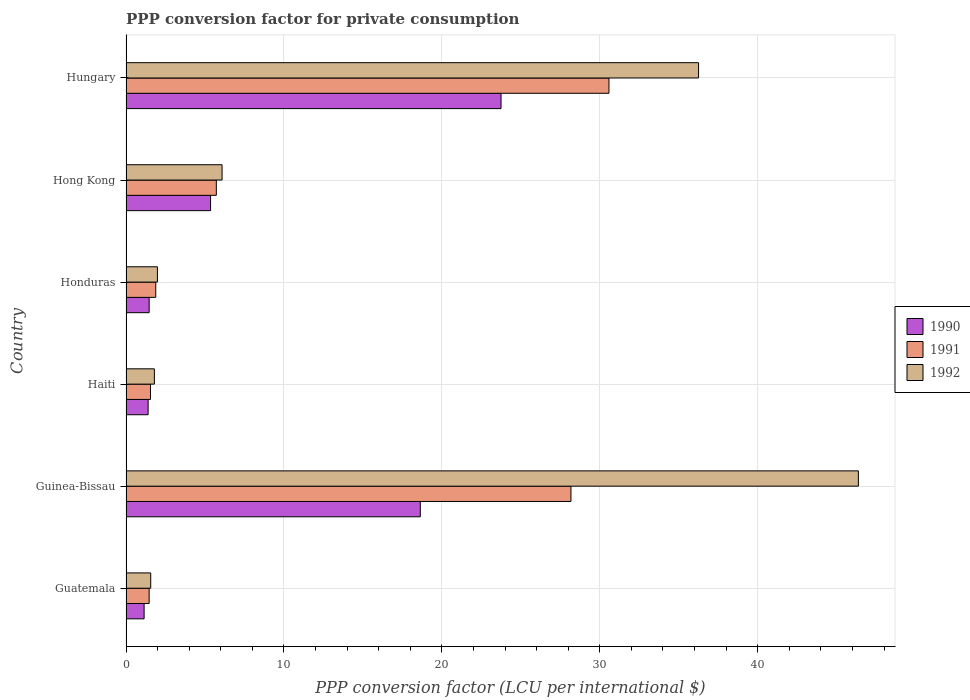How many groups of bars are there?
Offer a very short reply. 6. Are the number of bars on each tick of the Y-axis equal?
Make the answer very short. Yes. How many bars are there on the 4th tick from the bottom?
Make the answer very short. 3. What is the label of the 3rd group of bars from the top?
Your response must be concise. Honduras. In how many cases, is the number of bars for a given country not equal to the number of legend labels?
Provide a succinct answer. 0. What is the PPP conversion factor for private consumption in 1992 in Hungary?
Provide a succinct answer. 36.26. Across all countries, what is the maximum PPP conversion factor for private consumption in 1990?
Your answer should be very brief. 23.75. Across all countries, what is the minimum PPP conversion factor for private consumption in 1990?
Provide a short and direct response. 1.15. In which country was the PPP conversion factor for private consumption in 1992 maximum?
Your answer should be very brief. Guinea-Bissau. In which country was the PPP conversion factor for private consumption in 1990 minimum?
Your answer should be very brief. Guatemala. What is the total PPP conversion factor for private consumption in 1992 in the graph?
Give a very brief answer. 94.06. What is the difference between the PPP conversion factor for private consumption in 1991 in Hong Kong and that in Hungary?
Your answer should be very brief. -24.86. What is the difference between the PPP conversion factor for private consumption in 1991 in Honduras and the PPP conversion factor for private consumption in 1992 in Haiti?
Make the answer very short. 0.09. What is the average PPP conversion factor for private consumption in 1990 per country?
Give a very brief answer. 8.63. What is the difference between the PPP conversion factor for private consumption in 1991 and PPP conversion factor for private consumption in 1990 in Guinea-Bissau?
Make the answer very short. 9.54. What is the ratio of the PPP conversion factor for private consumption in 1990 in Guinea-Bissau to that in Honduras?
Make the answer very short. 12.71. Is the PPP conversion factor for private consumption in 1990 in Guatemala less than that in Haiti?
Offer a terse response. Yes. Is the difference between the PPP conversion factor for private consumption in 1991 in Guatemala and Haiti greater than the difference between the PPP conversion factor for private consumption in 1990 in Guatemala and Haiti?
Your answer should be very brief. Yes. What is the difference between the highest and the second highest PPP conversion factor for private consumption in 1992?
Offer a terse response. 10.12. What is the difference between the highest and the lowest PPP conversion factor for private consumption in 1991?
Your answer should be very brief. 29.12. In how many countries, is the PPP conversion factor for private consumption in 1992 greater than the average PPP conversion factor for private consumption in 1992 taken over all countries?
Your response must be concise. 2. Is the sum of the PPP conversion factor for private consumption in 1991 in Guatemala and Haiti greater than the maximum PPP conversion factor for private consumption in 1992 across all countries?
Your answer should be compact. No. Does the graph contain grids?
Ensure brevity in your answer.  Yes. How many legend labels are there?
Give a very brief answer. 3. How are the legend labels stacked?
Provide a succinct answer. Vertical. What is the title of the graph?
Ensure brevity in your answer.  PPP conversion factor for private consumption. Does "1985" appear as one of the legend labels in the graph?
Your answer should be compact. No. What is the label or title of the X-axis?
Provide a succinct answer. PPP conversion factor (LCU per international $). What is the PPP conversion factor (LCU per international $) in 1990 in Guatemala?
Give a very brief answer. 1.15. What is the PPP conversion factor (LCU per international $) of 1991 in Guatemala?
Provide a succinct answer. 1.46. What is the PPP conversion factor (LCU per international $) of 1992 in Guatemala?
Provide a succinct answer. 1.56. What is the PPP conversion factor (LCU per international $) of 1990 in Guinea-Bissau?
Your answer should be compact. 18.64. What is the PPP conversion factor (LCU per international $) in 1991 in Guinea-Bissau?
Your answer should be very brief. 28.18. What is the PPP conversion factor (LCU per international $) of 1992 in Guinea-Bissau?
Your answer should be compact. 46.38. What is the PPP conversion factor (LCU per international $) of 1990 in Haiti?
Provide a short and direct response. 1.4. What is the PPP conversion factor (LCU per international $) of 1991 in Haiti?
Give a very brief answer. 1.55. What is the PPP conversion factor (LCU per international $) in 1992 in Haiti?
Ensure brevity in your answer.  1.8. What is the PPP conversion factor (LCU per international $) in 1990 in Honduras?
Offer a terse response. 1.47. What is the PPP conversion factor (LCU per international $) in 1991 in Honduras?
Your response must be concise. 1.88. What is the PPP conversion factor (LCU per international $) of 1992 in Honduras?
Provide a short and direct response. 1.99. What is the PPP conversion factor (LCU per international $) in 1990 in Hong Kong?
Provide a succinct answer. 5.35. What is the PPP conversion factor (LCU per international $) in 1991 in Hong Kong?
Keep it short and to the point. 5.72. What is the PPP conversion factor (LCU per international $) of 1992 in Hong Kong?
Keep it short and to the point. 6.08. What is the PPP conversion factor (LCU per international $) of 1990 in Hungary?
Provide a short and direct response. 23.75. What is the PPP conversion factor (LCU per international $) of 1991 in Hungary?
Keep it short and to the point. 30.58. What is the PPP conversion factor (LCU per international $) of 1992 in Hungary?
Provide a succinct answer. 36.26. Across all countries, what is the maximum PPP conversion factor (LCU per international $) in 1990?
Provide a short and direct response. 23.75. Across all countries, what is the maximum PPP conversion factor (LCU per international $) in 1991?
Give a very brief answer. 30.58. Across all countries, what is the maximum PPP conversion factor (LCU per international $) in 1992?
Provide a succinct answer. 46.38. Across all countries, what is the minimum PPP conversion factor (LCU per international $) in 1990?
Give a very brief answer. 1.15. Across all countries, what is the minimum PPP conversion factor (LCU per international $) of 1991?
Offer a terse response. 1.46. Across all countries, what is the minimum PPP conversion factor (LCU per international $) in 1992?
Offer a very short reply. 1.56. What is the total PPP conversion factor (LCU per international $) of 1990 in the graph?
Make the answer very short. 51.75. What is the total PPP conversion factor (LCU per international $) of 1991 in the graph?
Provide a short and direct response. 69.38. What is the total PPP conversion factor (LCU per international $) of 1992 in the graph?
Offer a terse response. 94.06. What is the difference between the PPP conversion factor (LCU per international $) in 1990 in Guatemala and that in Guinea-Bissau?
Provide a succinct answer. -17.49. What is the difference between the PPP conversion factor (LCU per international $) of 1991 in Guatemala and that in Guinea-Bissau?
Your answer should be very brief. -26.71. What is the difference between the PPP conversion factor (LCU per international $) of 1992 in Guatemala and that in Guinea-Bissau?
Provide a succinct answer. -44.81. What is the difference between the PPP conversion factor (LCU per international $) in 1990 in Guatemala and that in Haiti?
Your response must be concise. -0.25. What is the difference between the PPP conversion factor (LCU per international $) of 1991 in Guatemala and that in Haiti?
Provide a succinct answer. -0.09. What is the difference between the PPP conversion factor (LCU per international $) of 1992 in Guatemala and that in Haiti?
Give a very brief answer. -0.23. What is the difference between the PPP conversion factor (LCU per international $) of 1990 in Guatemala and that in Honduras?
Offer a very short reply. -0.32. What is the difference between the PPP conversion factor (LCU per international $) in 1991 in Guatemala and that in Honduras?
Offer a terse response. -0.42. What is the difference between the PPP conversion factor (LCU per international $) in 1992 in Guatemala and that in Honduras?
Your answer should be very brief. -0.42. What is the difference between the PPP conversion factor (LCU per international $) of 1990 in Guatemala and that in Hong Kong?
Make the answer very short. -4.21. What is the difference between the PPP conversion factor (LCU per international $) of 1991 in Guatemala and that in Hong Kong?
Ensure brevity in your answer.  -4.25. What is the difference between the PPP conversion factor (LCU per international $) in 1992 in Guatemala and that in Hong Kong?
Keep it short and to the point. -4.52. What is the difference between the PPP conversion factor (LCU per international $) in 1990 in Guatemala and that in Hungary?
Your response must be concise. -22.6. What is the difference between the PPP conversion factor (LCU per international $) of 1991 in Guatemala and that in Hungary?
Your answer should be very brief. -29.12. What is the difference between the PPP conversion factor (LCU per international $) of 1992 in Guatemala and that in Hungary?
Provide a succinct answer. -34.69. What is the difference between the PPP conversion factor (LCU per international $) of 1990 in Guinea-Bissau and that in Haiti?
Give a very brief answer. 17.24. What is the difference between the PPP conversion factor (LCU per international $) of 1991 in Guinea-Bissau and that in Haiti?
Your response must be concise. 26.63. What is the difference between the PPP conversion factor (LCU per international $) in 1992 in Guinea-Bissau and that in Haiti?
Your response must be concise. 44.58. What is the difference between the PPP conversion factor (LCU per international $) of 1990 in Guinea-Bissau and that in Honduras?
Provide a succinct answer. 17.17. What is the difference between the PPP conversion factor (LCU per international $) in 1991 in Guinea-Bissau and that in Honduras?
Your response must be concise. 26.29. What is the difference between the PPP conversion factor (LCU per international $) in 1992 in Guinea-Bissau and that in Honduras?
Ensure brevity in your answer.  44.39. What is the difference between the PPP conversion factor (LCU per international $) of 1990 in Guinea-Bissau and that in Hong Kong?
Provide a succinct answer. 13.28. What is the difference between the PPP conversion factor (LCU per international $) of 1991 in Guinea-Bissau and that in Hong Kong?
Ensure brevity in your answer.  22.46. What is the difference between the PPP conversion factor (LCU per international $) in 1992 in Guinea-Bissau and that in Hong Kong?
Provide a short and direct response. 40.29. What is the difference between the PPP conversion factor (LCU per international $) of 1990 in Guinea-Bissau and that in Hungary?
Provide a succinct answer. -5.11. What is the difference between the PPP conversion factor (LCU per international $) in 1991 in Guinea-Bissau and that in Hungary?
Your response must be concise. -2.41. What is the difference between the PPP conversion factor (LCU per international $) in 1992 in Guinea-Bissau and that in Hungary?
Offer a terse response. 10.12. What is the difference between the PPP conversion factor (LCU per international $) in 1990 in Haiti and that in Honduras?
Keep it short and to the point. -0.07. What is the difference between the PPP conversion factor (LCU per international $) of 1991 in Haiti and that in Honduras?
Provide a succinct answer. -0.33. What is the difference between the PPP conversion factor (LCU per international $) in 1992 in Haiti and that in Honduras?
Provide a short and direct response. -0.19. What is the difference between the PPP conversion factor (LCU per international $) of 1990 in Haiti and that in Hong Kong?
Your answer should be very brief. -3.95. What is the difference between the PPP conversion factor (LCU per international $) of 1991 in Haiti and that in Hong Kong?
Make the answer very short. -4.17. What is the difference between the PPP conversion factor (LCU per international $) of 1992 in Haiti and that in Hong Kong?
Your answer should be compact. -4.29. What is the difference between the PPP conversion factor (LCU per international $) of 1990 in Haiti and that in Hungary?
Your answer should be compact. -22.35. What is the difference between the PPP conversion factor (LCU per international $) in 1991 in Haiti and that in Hungary?
Your answer should be very brief. -29.03. What is the difference between the PPP conversion factor (LCU per international $) of 1992 in Haiti and that in Hungary?
Make the answer very short. -34.46. What is the difference between the PPP conversion factor (LCU per international $) of 1990 in Honduras and that in Hong Kong?
Keep it short and to the point. -3.89. What is the difference between the PPP conversion factor (LCU per international $) in 1991 in Honduras and that in Hong Kong?
Your response must be concise. -3.84. What is the difference between the PPP conversion factor (LCU per international $) in 1992 in Honduras and that in Hong Kong?
Give a very brief answer. -4.09. What is the difference between the PPP conversion factor (LCU per international $) in 1990 in Honduras and that in Hungary?
Provide a succinct answer. -22.28. What is the difference between the PPP conversion factor (LCU per international $) of 1991 in Honduras and that in Hungary?
Your answer should be very brief. -28.7. What is the difference between the PPP conversion factor (LCU per international $) in 1992 in Honduras and that in Hungary?
Your answer should be compact. -34.27. What is the difference between the PPP conversion factor (LCU per international $) of 1990 in Hong Kong and that in Hungary?
Offer a terse response. -18.39. What is the difference between the PPP conversion factor (LCU per international $) in 1991 in Hong Kong and that in Hungary?
Your answer should be very brief. -24.86. What is the difference between the PPP conversion factor (LCU per international $) of 1992 in Hong Kong and that in Hungary?
Ensure brevity in your answer.  -30.17. What is the difference between the PPP conversion factor (LCU per international $) in 1990 in Guatemala and the PPP conversion factor (LCU per international $) in 1991 in Guinea-Bissau?
Provide a succinct answer. -27.03. What is the difference between the PPP conversion factor (LCU per international $) in 1990 in Guatemala and the PPP conversion factor (LCU per international $) in 1992 in Guinea-Bissau?
Your answer should be compact. -45.23. What is the difference between the PPP conversion factor (LCU per international $) of 1991 in Guatemala and the PPP conversion factor (LCU per international $) of 1992 in Guinea-Bissau?
Make the answer very short. -44.91. What is the difference between the PPP conversion factor (LCU per international $) of 1990 in Guatemala and the PPP conversion factor (LCU per international $) of 1991 in Haiti?
Provide a succinct answer. -0.4. What is the difference between the PPP conversion factor (LCU per international $) in 1990 in Guatemala and the PPP conversion factor (LCU per international $) in 1992 in Haiti?
Give a very brief answer. -0.65. What is the difference between the PPP conversion factor (LCU per international $) in 1991 in Guatemala and the PPP conversion factor (LCU per international $) in 1992 in Haiti?
Your response must be concise. -0.33. What is the difference between the PPP conversion factor (LCU per international $) in 1990 in Guatemala and the PPP conversion factor (LCU per international $) in 1991 in Honduras?
Offer a terse response. -0.74. What is the difference between the PPP conversion factor (LCU per international $) of 1990 in Guatemala and the PPP conversion factor (LCU per international $) of 1992 in Honduras?
Keep it short and to the point. -0.84. What is the difference between the PPP conversion factor (LCU per international $) of 1991 in Guatemala and the PPP conversion factor (LCU per international $) of 1992 in Honduras?
Make the answer very short. -0.52. What is the difference between the PPP conversion factor (LCU per international $) in 1990 in Guatemala and the PPP conversion factor (LCU per international $) in 1991 in Hong Kong?
Provide a short and direct response. -4.57. What is the difference between the PPP conversion factor (LCU per international $) in 1990 in Guatemala and the PPP conversion factor (LCU per international $) in 1992 in Hong Kong?
Your response must be concise. -4.94. What is the difference between the PPP conversion factor (LCU per international $) in 1991 in Guatemala and the PPP conversion factor (LCU per international $) in 1992 in Hong Kong?
Your answer should be very brief. -4.62. What is the difference between the PPP conversion factor (LCU per international $) in 1990 in Guatemala and the PPP conversion factor (LCU per international $) in 1991 in Hungary?
Ensure brevity in your answer.  -29.44. What is the difference between the PPP conversion factor (LCU per international $) of 1990 in Guatemala and the PPP conversion factor (LCU per international $) of 1992 in Hungary?
Make the answer very short. -35.11. What is the difference between the PPP conversion factor (LCU per international $) in 1991 in Guatemala and the PPP conversion factor (LCU per international $) in 1992 in Hungary?
Provide a short and direct response. -34.79. What is the difference between the PPP conversion factor (LCU per international $) in 1990 in Guinea-Bissau and the PPP conversion factor (LCU per international $) in 1991 in Haiti?
Ensure brevity in your answer.  17.09. What is the difference between the PPP conversion factor (LCU per international $) of 1990 in Guinea-Bissau and the PPP conversion factor (LCU per international $) of 1992 in Haiti?
Provide a short and direct response. 16.84. What is the difference between the PPP conversion factor (LCU per international $) in 1991 in Guinea-Bissau and the PPP conversion factor (LCU per international $) in 1992 in Haiti?
Your answer should be very brief. 26.38. What is the difference between the PPP conversion factor (LCU per international $) in 1990 in Guinea-Bissau and the PPP conversion factor (LCU per international $) in 1991 in Honduras?
Keep it short and to the point. 16.75. What is the difference between the PPP conversion factor (LCU per international $) of 1990 in Guinea-Bissau and the PPP conversion factor (LCU per international $) of 1992 in Honduras?
Provide a succinct answer. 16.65. What is the difference between the PPP conversion factor (LCU per international $) in 1991 in Guinea-Bissau and the PPP conversion factor (LCU per international $) in 1992 in Honduras?
Your answer should be compact. 26.19. What is the difference between the PPP conversion factor (LCU per international $) in 1990 in Guinea-Bissau and the PPP conversion factor (LCU per international $) in 1991 in Hong Kong?
Your response must be concise. 12.92. What is the difference between the PPP conversion factor (LCU per international $) of 1990 in Guinea-Bissau and the PPP conversion factor (LCU per international $) of 1992 in Hong Kong?
Your answer should be very brief. 12.55. What is the difference between the PPP conversion factor (LCU per international $) of 1991 in Guinea-Bissau and the PPP conversion factor (LCU per international $) of 1992 in Hong Kong?
Your answer should be very brief. 22.09. What is the difference between the PPP conversion factor (LCU per international $) in 1990 in Guinea-Bissau and the PPP conversion factor (LCU per international $) in 1991 in Hungary?
Your answer should be very brief. -11.95. What is the difference between the PPP conversion factor (LCU per international $) of 1990 in Guinea-Bissau and the PPP conversion factor (LCU per international $) of 1992 in Hungary?
Offer a terse response. -17.62. What is the difference between the PPP conversion factor (LCU per international $) in 1991 in Guinea-Bissau and the PPP conversion factor (LCU per international $) in 1992 in Hungary?
Make the answer very short. -8.08. What is the difference between the PPP conversion factor (LCU per international $) in 1990 in Haiti and the PPP conversion factor (LCU per international $) in 1991 in Honduras?
Offer a very short reply. -0.48. What is the difference between the PPP conversion factor (LCU per international $) in 1990 in Haiti and the PPP conversion factor (LCU per international $) in 1992 in Honduras?
Offer a terse response. -0.59. What is the difference between the PPP conversion factor (LCU per international $) in 1991 in Haiti and the PPP conversion factor (LCU per international $) in 1992 in Honduras?
Your answer should be compact. -0.44. What is the difference between the PPP conversion factor (LCU per international $) in 1990 in Haiti and the PPP conversion factor (LCU per international $) in 1991 in Hong Kong?
Offer a terse response. -4.32. What is the difference between the PPP conversion factor (LCU per international $) in 1990 in Haiti and the PPP conversion factor (LCU per international $) in 1992 in Hong Kong?
Offer a very short reply. -4.68. What is the difference between the PPP conversion factor (LCU per international $) of 1991 in Haiti and the PPP conversion factor (LCU per international $) of 1992 in Hong Kong?
Your answer should be compact. -4.53. What is the difference between the PPP conversion factor (LCU per international $) of 1990 in Haiti and the PPP conversion factor (LCU per international $) of 1991 in Hungary?
Give a very brief answer. -29.18. What is the difference between the PPP conversion factor (LCU per international $) of 1990 in Haiti and the PPP conversion factor (LCU per international $) of 1992 in Hungary?
Make the answer very short. -34.86. What is the difference between the PPP conversion factor (LCU per international $) of 1991 in Haiti and the PPP conversion factor (LCU per international $) of 1992 in Hungary?
Give a very brief answer. -34.71. What is the difference between the PPP conversion factor (LCU per international $) of 1990 in Honduras and the PPP conversion factor (LCU per international $) of 1991 in Hong Kong?
Your answer should be compact. -4.25. What is the difference between the PPP conversion factor (LCU per international $) of 1990 in Honduras and the PPP conversion factor (LCU per international $) of 1992 in Hong Kong?
Provide a succinct answer. -4.62. What is the difference between the PPP conversion factor (LCU per international $) in 1991 in Honduras and the PPP conversion factor (LCU per international $) in 1992 in Hong Kong?
Provide a short and direct response. -4.2. What is the difference between the PPP conversion factor (LCU per international $) of 1990 in Honduras and the PPP conversion factor (LCU per international $) of 1991 in Hungary?
Provide a short and direct response. -29.12. What is the difference between the PPP conversion factor (LCU per international $) in 1990 in Honduras and the PPP conversion factor (LCU per international $) in 1992 in Hungary?
Make the answer very short. -34.79. What is the difference between the PPP conversion factor (LCU per international $) in 1991 in Honduras and the PPP conversion factor (LCU per international $) in 1992 in Hungary?
Give a very brief answer. -34.37. What is the difference between the PPP conversion factor (LCU per international $) of 1990 in Hong Kong and the PPP conversion factor (LCU per international $) of 1991 in Hungary?
Your response must be concise. -25.23. What is the difference between the PPP conversion factor (LCU per international $) in 1990 in Hong Kong and the PPP conversion factor (LCU per international $) in 1992 in Hungary?
Ensure brevity in your answer.  -30.9. What is the difference between the PPP conversion factor (LCU per international $) in 1991 in Hong Kong and the PPP conversion factor (LCU per international $) in 1992 in Hungary?
Make the answer very short. -30.54. What is the average PPP conversion factor (LCU per international $) in 1990 per country?
Make the answer very short. 8.63. What is the average PPP conversion factor (LCU per international $) of 1991 per country?
Your answer should be very brief. 11.56. What is the average PPP conversion factor (LCU per international $) in 1992 per country?
Your answer should be compact. 15.68. What is the difference between the PPP conversion factor (LCU per international $) of 1990 and PPP conversion factor (LCU per international $) of 1991 in Guatemala?
Your response must be concise. -0.32. What is the difference between the PPP conversion factor (LCU per international $) in 1990 and PPP conversion factor (LCU per international $) in 1992 in Guatemala?
Give a very brief answer. -0.42. What is the difference between the PPP conversion factor (LCU per international $) in 1991 and PPP conversion factor (LCU per international $) in 1992 in Guatemala?
Keep it short and to the point. -0.1. What is the difference between the PPP conversion factor (LCU per international $) of 1990 and PPP conversion factor (LCU per international $) of 1991 in Guinea-Bissau?
Give a very brief answer. -9.54. What is the difference between the PPP conversion factor (LCU per international $) in 1990 and PPP conversion factor (LCU per international $) in 1992 in Guinea-Bissau?
Your response must be concise. -27.74. What is the difference between the PPP conversion factor (LCU per international $) of 1991 and PPP conversion factor (LCU per international $) of 1992 in Guinea-Bissau?
Provide a short and direct response. -18.2. What is the difference between the PPP conversion factor (LCU per international $) in 1990 and PPP conversion factor (LCU per international $) in 1991 in Haiti?
Ensure brevity in your answer.  -0.15. What is the difference between the PPP conversion factor (LCU per international $) of 1990 and PPP conversion factor (LCU per international $) of 1992 in Haiti?
Your answer should be compact. -0.4. What is the difference between the PPP conversion factor (LCU per international $) of 1991 and PPP conversion factor (LCU per international $) of 1992 in Haiti?
Your answer should be compact. -0.25. What is the difference between the PPP conversion factor (LCU per international $) in 1990 and PPP conversion factor (LCU per international $) in 1991 in Honduras?
Ensure brevity in your answer.  -0.42. What is the difference between the PPP conversion factor (LCU per international $) of 1990 and PPP conversion factor (LCU per international $) of 1992 in Honduras?
Your response must be concise. -0.52. What is the difference between the PPP conversion factor (LCU per international $) in 1991 and PPP conversion factor (LCU per international $) in 1992 in Honduras?
Offer a very short reply. -0.1. What is the difference between the PPP conversion factor (LCU per international $) of 1990 and PPP conversion factor (LCU per international $) of 1991 in Hong Kong?
Give a very brief answer. -0.37. What is the difference between the PPP conversion factor (LCU per international $) in 1990 and PPP conversion factor (LCU per international $) in 1992 in Hong Kong?
Your answer should be compact. -0.73. What is the difference between the PPP conversion factor (LCU per international $) in 1991 and PPP conversion factor (LCU per international $) in 1992 in Hong Kong?
Your answer should be compact. -0.36. What is the difference between the PPP conversion factor (LCU per international $) in 1990 and PPP conversion factor (LCU per international $) in 1991 in Hungary?
Offer a very short reply. -6.83. What is the difference between the PPP conversion factor (LCU per international $) in 1990 and PPP conversion factor (LCU per international $) in 1992 in Hungary?
Your answer should be very brief. -12.51. What is the difference between the PPP conversion factor (LCU per international $) in 1991 and PPP conversion factor (LCU per international $) in 1992 in Hungary?
Offer a very short reply. -5.67. What is the ratio of the PPP conversion factor (LCU per international $) of 1990 in Guatemala to that in Guinea-Bissau?
Your answer should be compact. 0.06. What is the ratio of the PPP conversion factor (LCU per international $) in 1991 in Guatemala to that in Guinea-Bissau?
Your answer should be very brief. 0.05. What is the ratio of the PPP conversion factor (LCU per international $) in 1992 in Guatemala to that in Guinea-Bissau?
Your answer should be very brief. 0.03. What is the ratio of the PPP conversion factor (LCU per international $) in 1990 in Guatemala to that in Haiti?
Offer a terse response. 0.82. What is the ratio of the PPP conversion factor (LCU per international $) in 1991 in Guatemala to that in Haiti?
Make the answer very short. 0.94. What is the ratio of the PPP conversion factor (LCU per international $) in 1992 in Guatemala to that in Haiti?
Ensure brevity in your answer.  0.87. What is the ratio of the PPP conversion factor (LCU per international $) in 1990 in Guatemala to that in Honduras?
Your response must be concise. 0.78. What is the ratio of the PPP conversion factor (LCU per international $) of 1991 in Guatemala to that in Honduras?
Your response must be concise. 0.78. What is the ratio of the PPP conversion factor (LCU per international $) of 1992 in Guatemala to that in Honduras?
Make the answer very short. 0.79. What is the ratio of the PPP conversion factor (LCU per international $) of 1990 in Guatemala to that in Hong Kong?
Offer a terse response. 0.21. What is the ratio of the PPP conversion factor (LCU per international $) in 1991 in Guatemala to that in Hong Kong?
Offer a terse response. 0.26. What is the ratio of the PPP conversion factor (LCU per international $) in 1992 in Guatemala to that in Hong Kong?
Your response must be concise. 0.26. What is the ratio of the PPP conversion factor (LCU per international $) of 1990 in Guatemala to that in Hungary?
Provide a short and direct response. 0.05. What is the ratio of the PPP conversion factor (LCU per international $) of 1991 in Guatemala to that in Hungary?
Keep it short and to the point. 0.05. What is the ratio of the PPP conversion factor (LCU per international $) in 1992 in Guatemala to that in Hungary?
Give a very brief answer. 0.04. What is the ratio of the PPP conversion factor (LCU per international $) in 1990 in Guinea-Bissau to that in Haiti?
Your response must be concise. 13.31. What is the ratio of the PPP conversion factor (LCU per international $) of 1991 in Guinea-Bissau to that in Haiti?
Your response must be concise. 18.17. What is the ratio of the PPP conversion factor (LCU per international $) of 1992 in Guinea-Bissau to that in Haiti?
Ensure brevity in your answer.  25.82. What is the ratio of the PPP conversion factor (LCU per international $) of 1990 in Guinea-Bissau to that in Honduras?
Ensure brevity in your answer.  12.71. What is the ratio of the PPP conversion factor (LCU per international $) in 1991 in Guinea-Bissau to that in Honduras?
Your answer should be very brief. 14.96. What is the ratio of the PPP conversion factor (LCU per international $) of 1992 in Guinea-Bissau to that in Honduras?
Offer a terse response. 23.32. What is the ratio of the PPP conversion factor (LCU per international $) of 1990 in Guinea-Bissau to that in Hong Kong?
Provide a succinct answer. 3.48. What is the ratio of the PPP conversion factor (LCU per international $) of 1991 in Guinea-Bissau to that in Hong Kong?
Provide a short and direct response. 4.93. What is the ratio of the PPP conversion factor (LCU per international $) of 1992 in Guinea-Bissau to that in Hong Kong?
Your answer should be very brief. 7.63. What is the ratio of the PPP conversion factor (LCU per international $) in 1990 in Guinea-Bissau to that in Hungary?
Provide a succinct answer. 0.78. What is the ratio of the PPP conversion factor (LCU per international $) of 1991 in Guinea-Bissau to that in Hungary?
Offer a very short reply. 0.92. What is the ratio of the PPP conversion factor (LCU per international $) in 1992 in Guinea-Bissau to that in Hungary?
Your response must be concise. 1.28. What is the ratio of the PPP conversion factor (LCU per international $) of 1990 in Haiti to that in Honduras?
Provide a succinct answer. 0.96. What is the ratio of the PPP conversion factor (LCU per international $) in 1991 in Haiti to that in Honduras?
Keep it short and to the point. 0.82. What is the ratio of the PPP conversion factor (LCU per international $) in 1992 in Haiti to that in Honduras?
Ensure brevity in your answer.  0.9. What is the ratio of the PPP conversion factor (LCU per international $) of 1990 in Haiti to that in Hong Kong?
Your answer should be very brief. 0.26. What is the ratio of the PPP conversion factor (LCU per international $) in 1991 in Haiti to that in Hong Kong?
Give a very brief answer. 0.27. What is the ratio of the PPP conversion factor (LCU per international $) in 1992 in Haiti to that in Hong Kong?
Your response must be concise. 0.3. What is the ratio of the PPP conversion factor (LCU per international $) in 1990 in Haiti to that in Hungary?
Provide a succinct answer. 0.06. What is the ratio of the PPP conversion factor (LCU per international $) of 1991 in Haiti to that in Hungary?
Ensure brevity in your answer.  0.05. What is the ratio of the PPP conversion factor (LCU per international $) in 1992 in Haiti to that in Hungary?
Offer a terse response. 0.05. What is the ratio of the PPP conversion factor (LCU per international $) in 1990 in Honduras to that in Hong Kong?
Offer a very short reply. 0.27. What is the ratio of the PPP conversion factor (LCU per international $) of 1991 in Honduras to that in Hong Kong?
Your response must be concise. 0.33. What is the ratio of the PPP conversion factor (LCU per international $) in 1992 in Honduras to that in Hong Kong?
Your answer should be very brief. 0.33. What is the ratio of the PPP conversion factor (LCU per international $) of 1990 in Honduras to that in Hungary?
Your answer should be very brief. 0.06. What is the ratio of the PPP conversion factor (LCU per international $) of 1991 in Honduras to that in Hungary?
Offer a terse response. 0.06. What is the ratio of the PPP conversion factor (LCU per international $) in 1992 in Honduras to that in Hungary?
Your response must be concise. 0.05. What is the ratio of the PPP conversion factor (LCU per international $) in 1990 in Hong Kong to that in Hungary?
Your answer should be compact. 0.23. What is the ratio of the PPP conversion factor (LCU per international $) of 1991 in Hong Kong to that in Hungary?
Keep it short and to the point. 0.19. What is the ratio of the PPP conversion factor (LCU per international $) in 1992 in Hong Kong to that in Hungary?
Offer a very short reply. 0.17. What is the difference between the highest and the second highest PPP conversion factor (LCU per international $) of 1990?
Give a very brief answer. 5.11. What is the difference between the highest and the second highest PPP conversion factor (LCU per international $) in 1991?
Your answer should be compact. 2.41. What is the difference between the highest and the second highest PPP conversion factor (LCU per international $) in 1992?
Your answer should be compact. 10.12. What is the difference between the highest and the lowest PPP conversion factor (LCU per international $) in 1990?
Offer a terse response. 22.6. What is the difference between the highest and the lowest PPP conversion factor (LCU per international $) of 1991?
Keep it short and to the point. 29.12. What is the difference between the highest and the lowest PPP conversion factor (LCU per international $) in 1992?
Your answer should be compact. 44.81. 